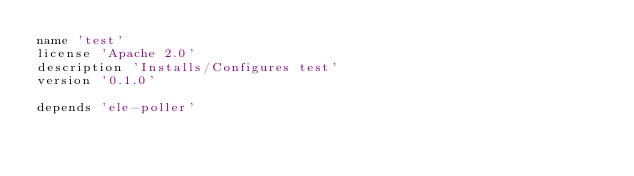Convert code to text. <code><loc_0><loc_0><loc_500><loc_500><_Ruby_>name 'test'
license 'Apache 2.0'
description 'Installs/Configures test'
version '0.1.0'

depends 'ele-poller'
</code> 